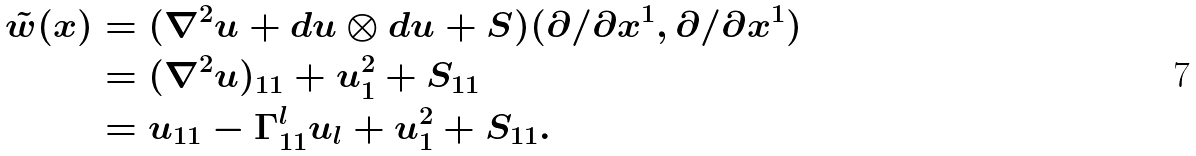Convert formula to latex. <formula><loc_0><loc_0><loc_500><loc_500>\tilde { w } ( x ) & = ( \nabla ^ { 2 } u + d u \otimes d u + S ) ( { \partial } / { \partial x ^ { 1 } } , { \partial } / { \partial x ^ { 1 } } ) \\ & = ( \nabla ^ { 2 } u ) _ { 1 1 } + u _ { 1 } ^ { 2 } + S _ { 1 1 } \\ & = u _ { 1 1 } - \Gamma ^ { l } _ { 1 1 } u _ { l } + u _ { 1 } ^ { 2 } + S _ { 1 1 } .</formula> 